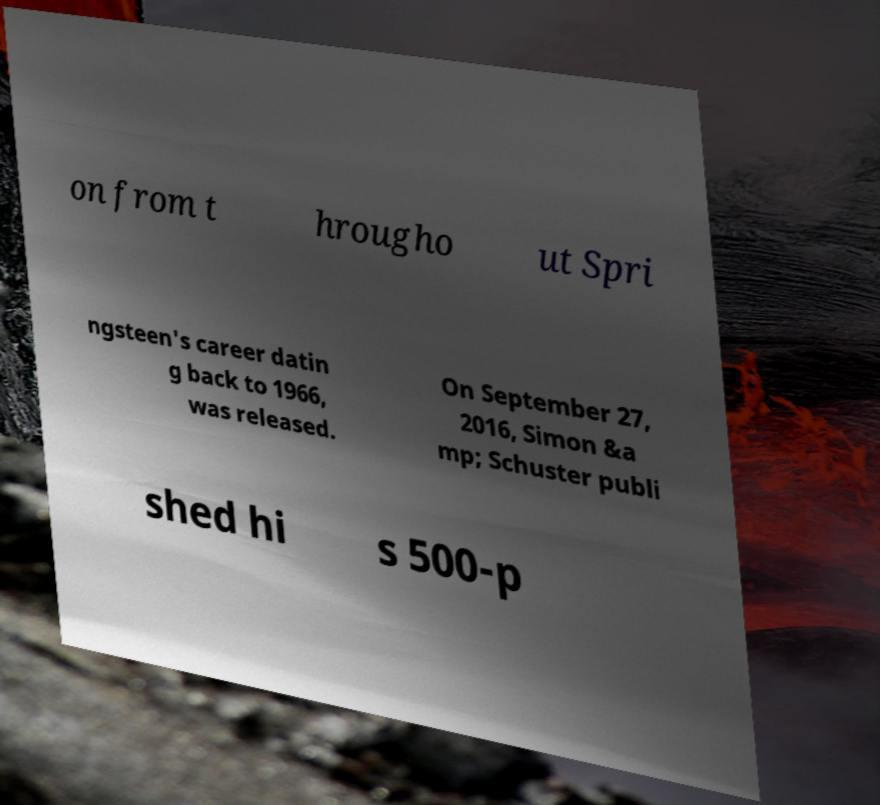Please identify and transcribe the text found in this image. on from t hrougho ut Spri ngsteen's career datin g back to 1966, was released. On September 27, 2016, Simon &a mp; Schuster publi shed hi s 500-p 